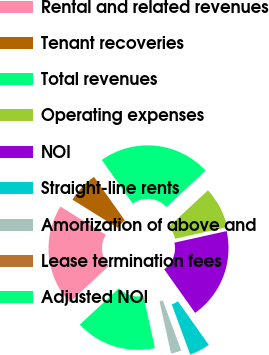<chart> <loc_0><loc_0><loc_500><loc_500><pie_chart><fcel>Rental and related revenues<fcel>Tenant recoveries<fcel>Total revenues<fcel>Operating expenses<fcel>NOI<fcel>Straight-line rents<fcel>Amortization of above and<fcel>Lease termination fees<fcel>Adjusted NOI<nl><fcel>20.76%<fcel>6.34%<fcel>22.87%<fcel>8.45%<fcel>18.65%<fcel>4.23%<fcel>2.12%<fcel>0.01%<fcel>16.54%<nl></chart> 